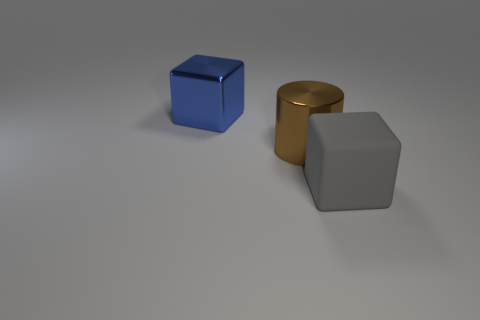Add 1 large cylinders. How many objects exist? 4 Subtract all cylinders. How many objects are left? 2 Subtract 0 purple balls. How many objects are left? 3 Subtract all cylinders. Subtract all large brown cylinders. How many objects are left? 1 Add 2 blocks. How many blocks are left? 4 Add 2 blocks. How many blocks exist? 4 